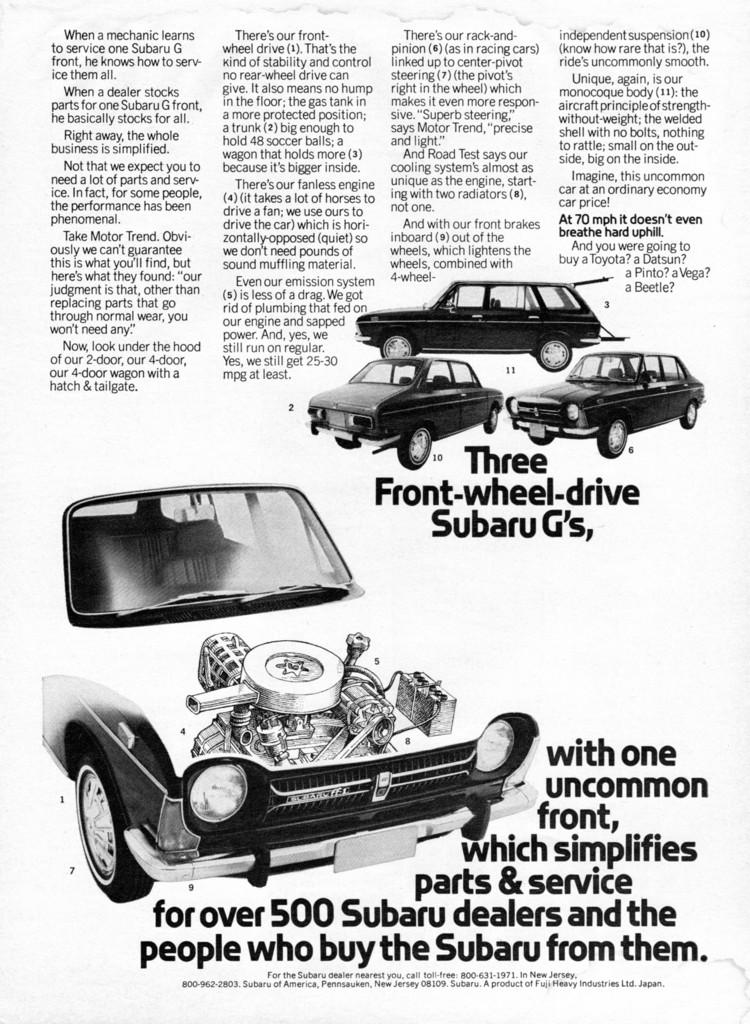What is the person in the image holding? In the first image, the person is holding a camera. In the second image, the person is holding a book. In the third image, the person is not holding anything. In the fourth image, the group of people is not holding anything. In the fifth image, the person is holding a cup of tea. In the sixth image, the person is not holding anything. In the seventh image, the person is not holding anything. In the eighth image, the person is not holding anything. What is on the table in the second image? In the second image, there is a laptop and a cup of coffee on the table. What color is the car in the third image? In the third image, the car is red in color. What is near the monument in the fourth image? In the fourth image, a group of people is standing near the monument. What is on the desk in the fifth image? In the fifth image, there is a computer and a cup of tea on the desk. What is the person riding in the sixth image? In the sixth image, the person is riding a bicycle. What is in the background of the seventh image? In the seventh image, there are trees and a playground in the background. What is the person standing near in the eighth image? In the eighth image, the person is standing near a river. Absurd Question/Answer: What type of glass can be seen in the aftermath of the event in the image? There is no event or glass present in any of the images. What type of yoke can be seen in the image? There is no yoke present in any of the images. 